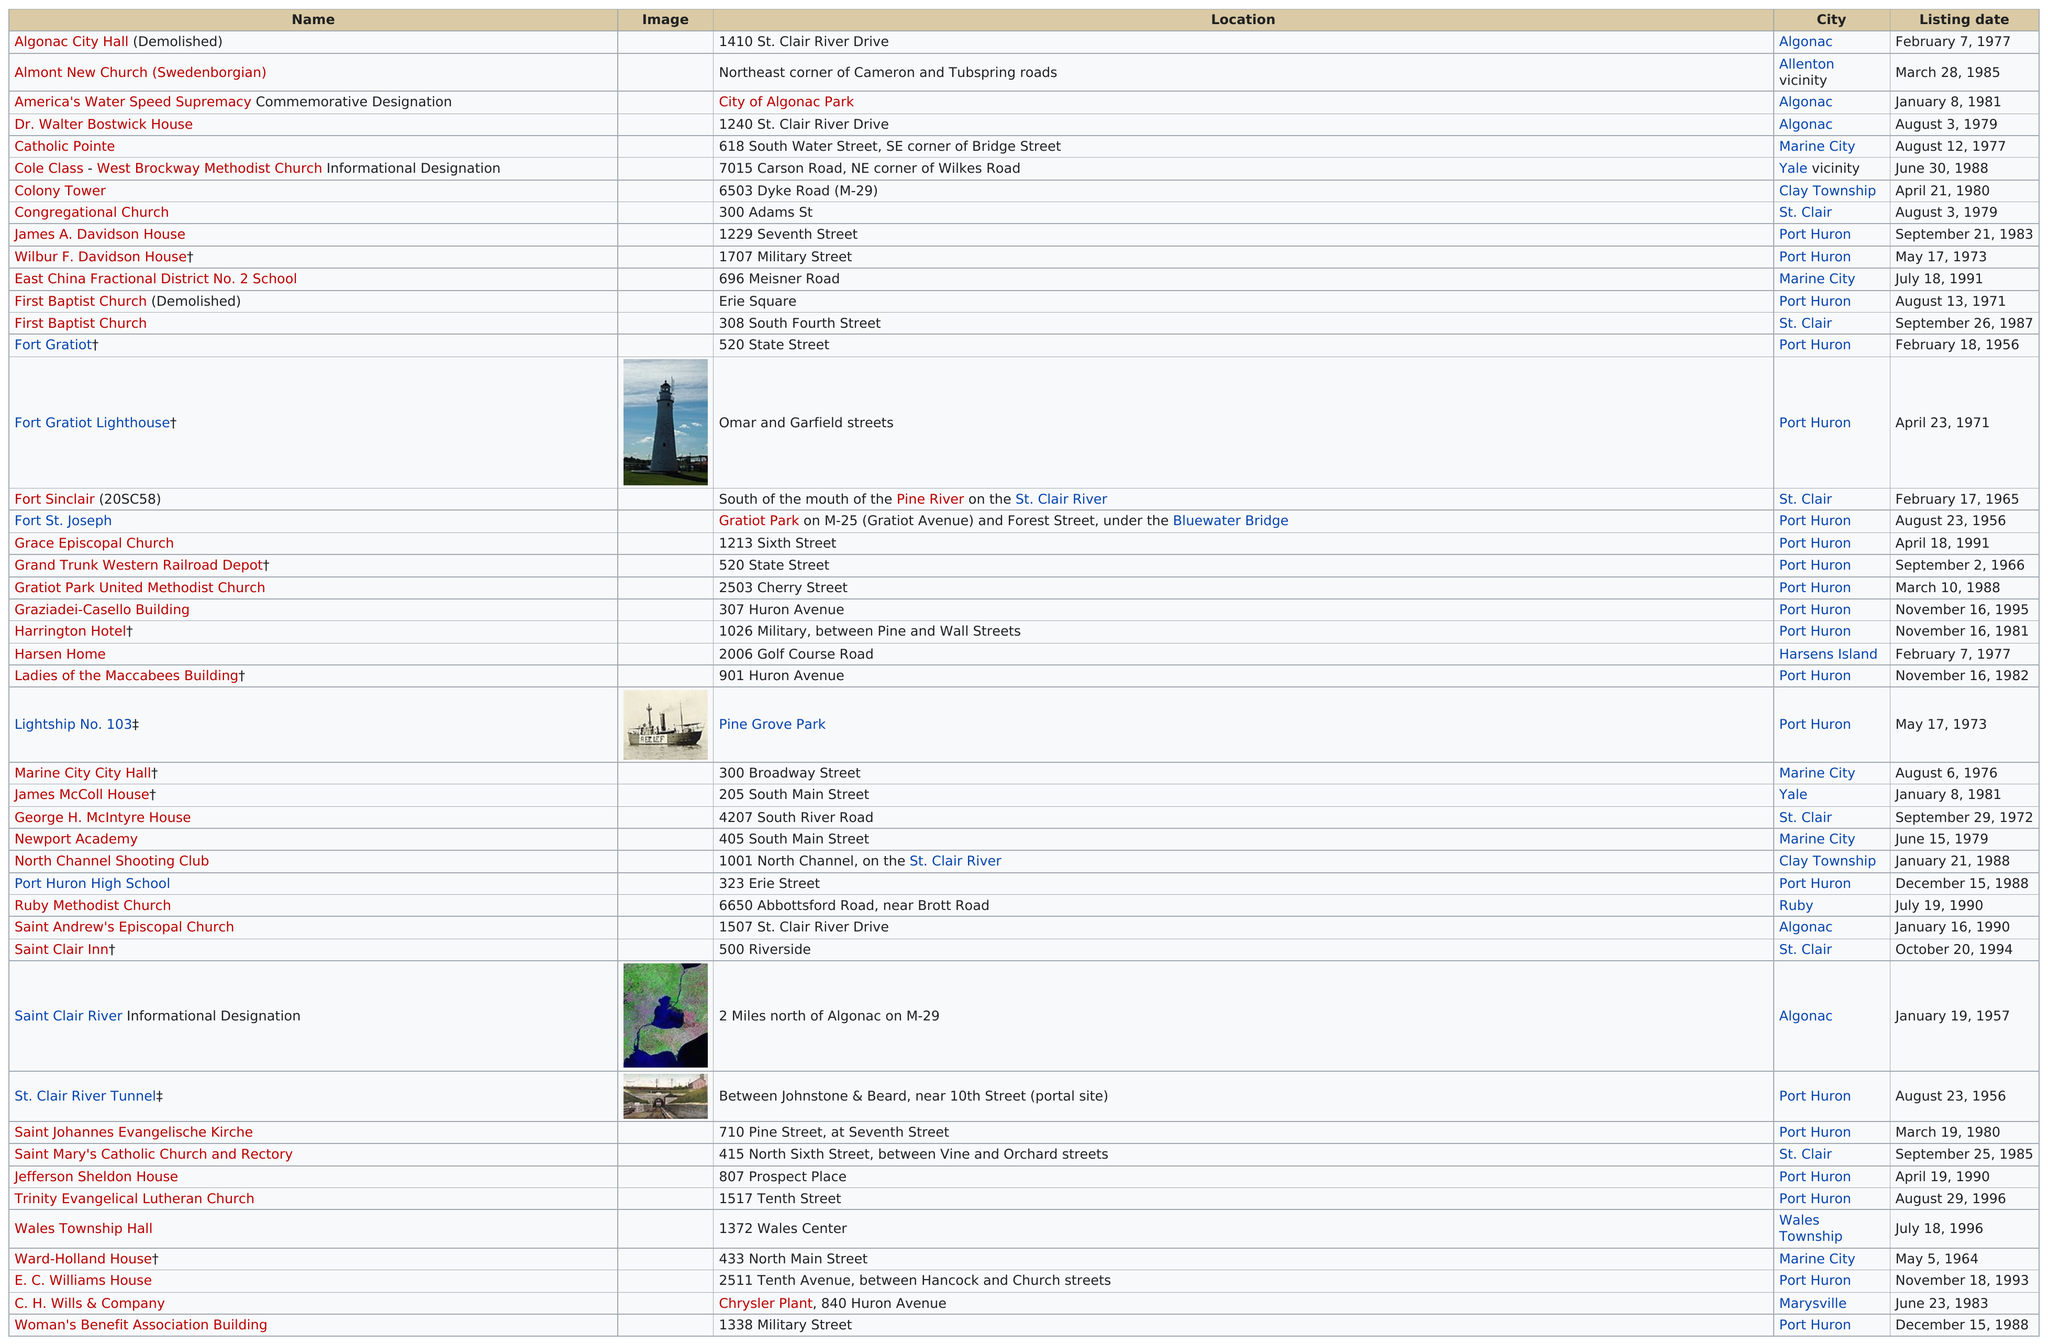Give some essential details in this illustration. In 1977, a total of three listings were added. Port Huron is home to the Fort Gratiot Lighthouse and Fort St. Joseph, which are located in the city. Of the names, 41 do not have images next to them. Out of all the cities surveyed, Port Huron had the most sites listed in the National Register of Historic Places. There are four names that have an image displayed next to them. 